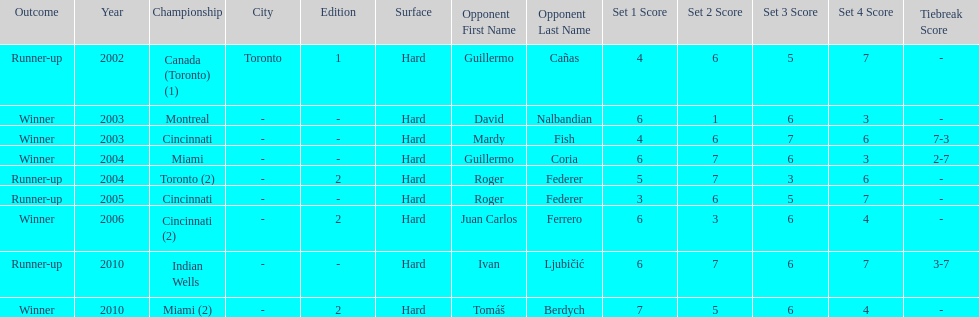How many times was roger federer a runner-up? 2. 